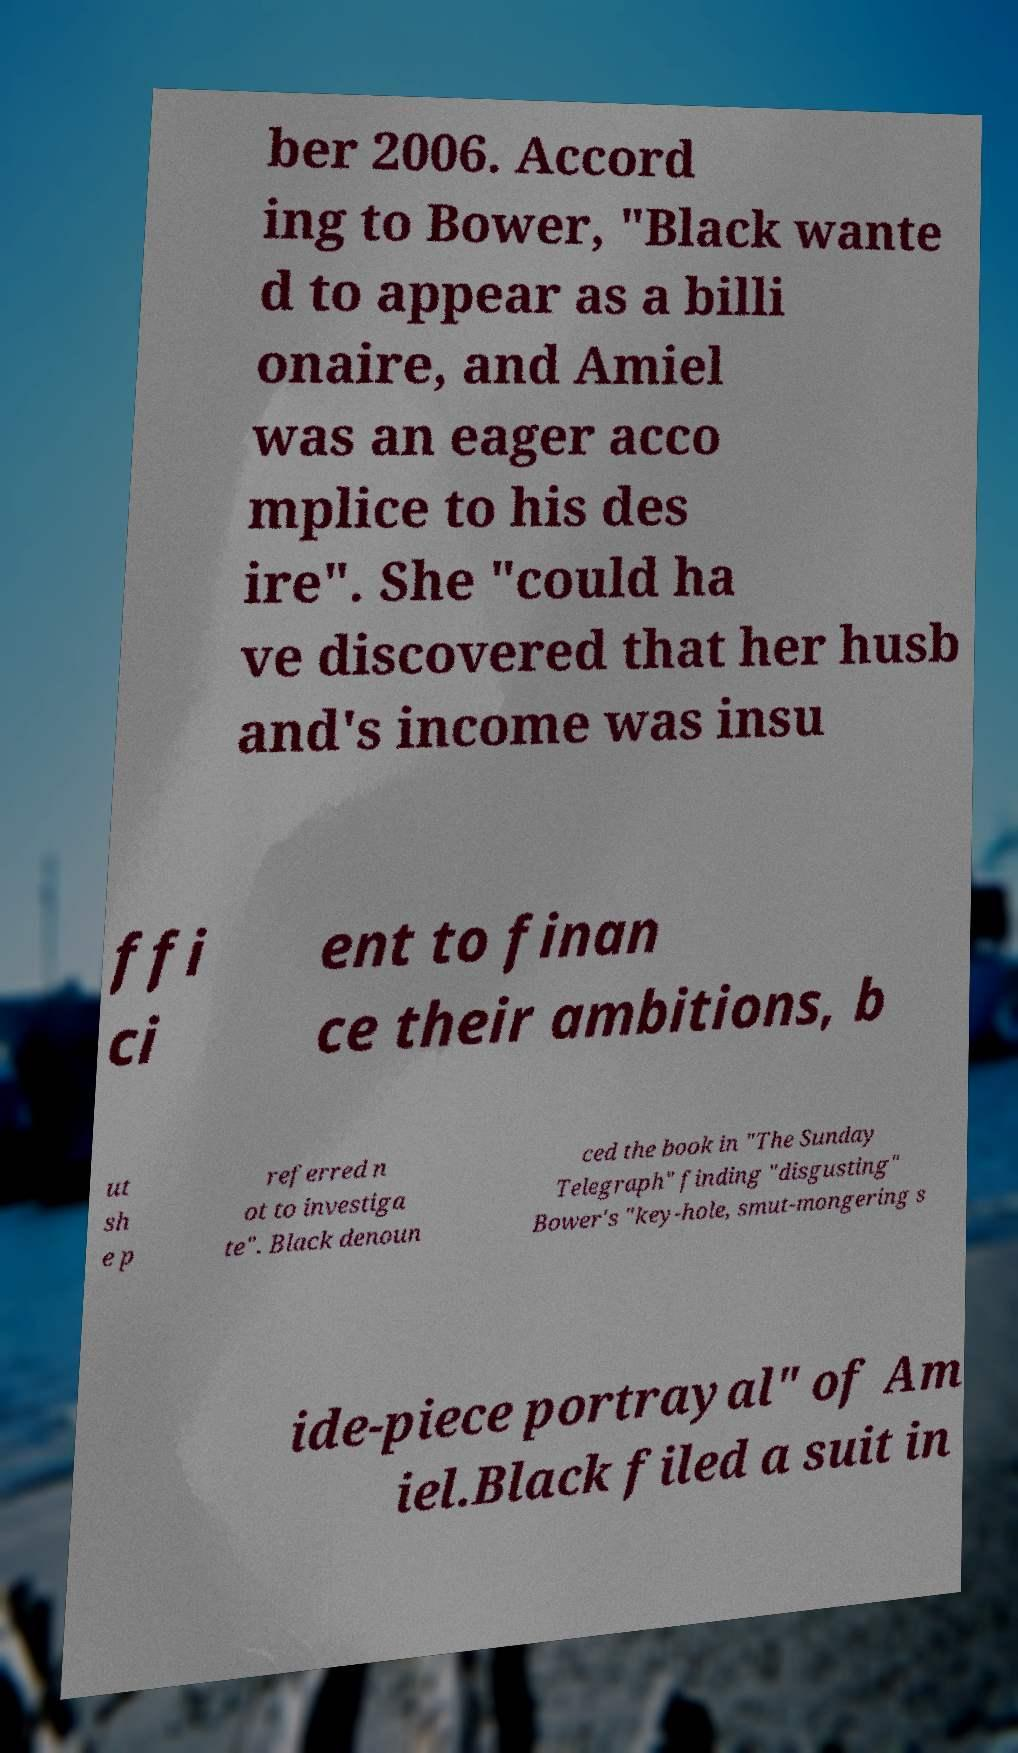Could you assist in decoding the text presented in this image and type it out clearly? ber 2006. Accord ing to Bower, "Black wante d to appear as a billi onaire, and Amiel was an eager acco mplice to his des ire". She "could ha ve discovered that her husb and's income was insu ffi ci ent to finan ce their ambitions, b ut sh e p referred n ot to investiga te". Black denoun ced the book in "The Sunday Telegraph" finding "disgusting" Bower's "key-hole, smut-mongering s ide-piece portrayal" of Am iel.Black filed a suit in 